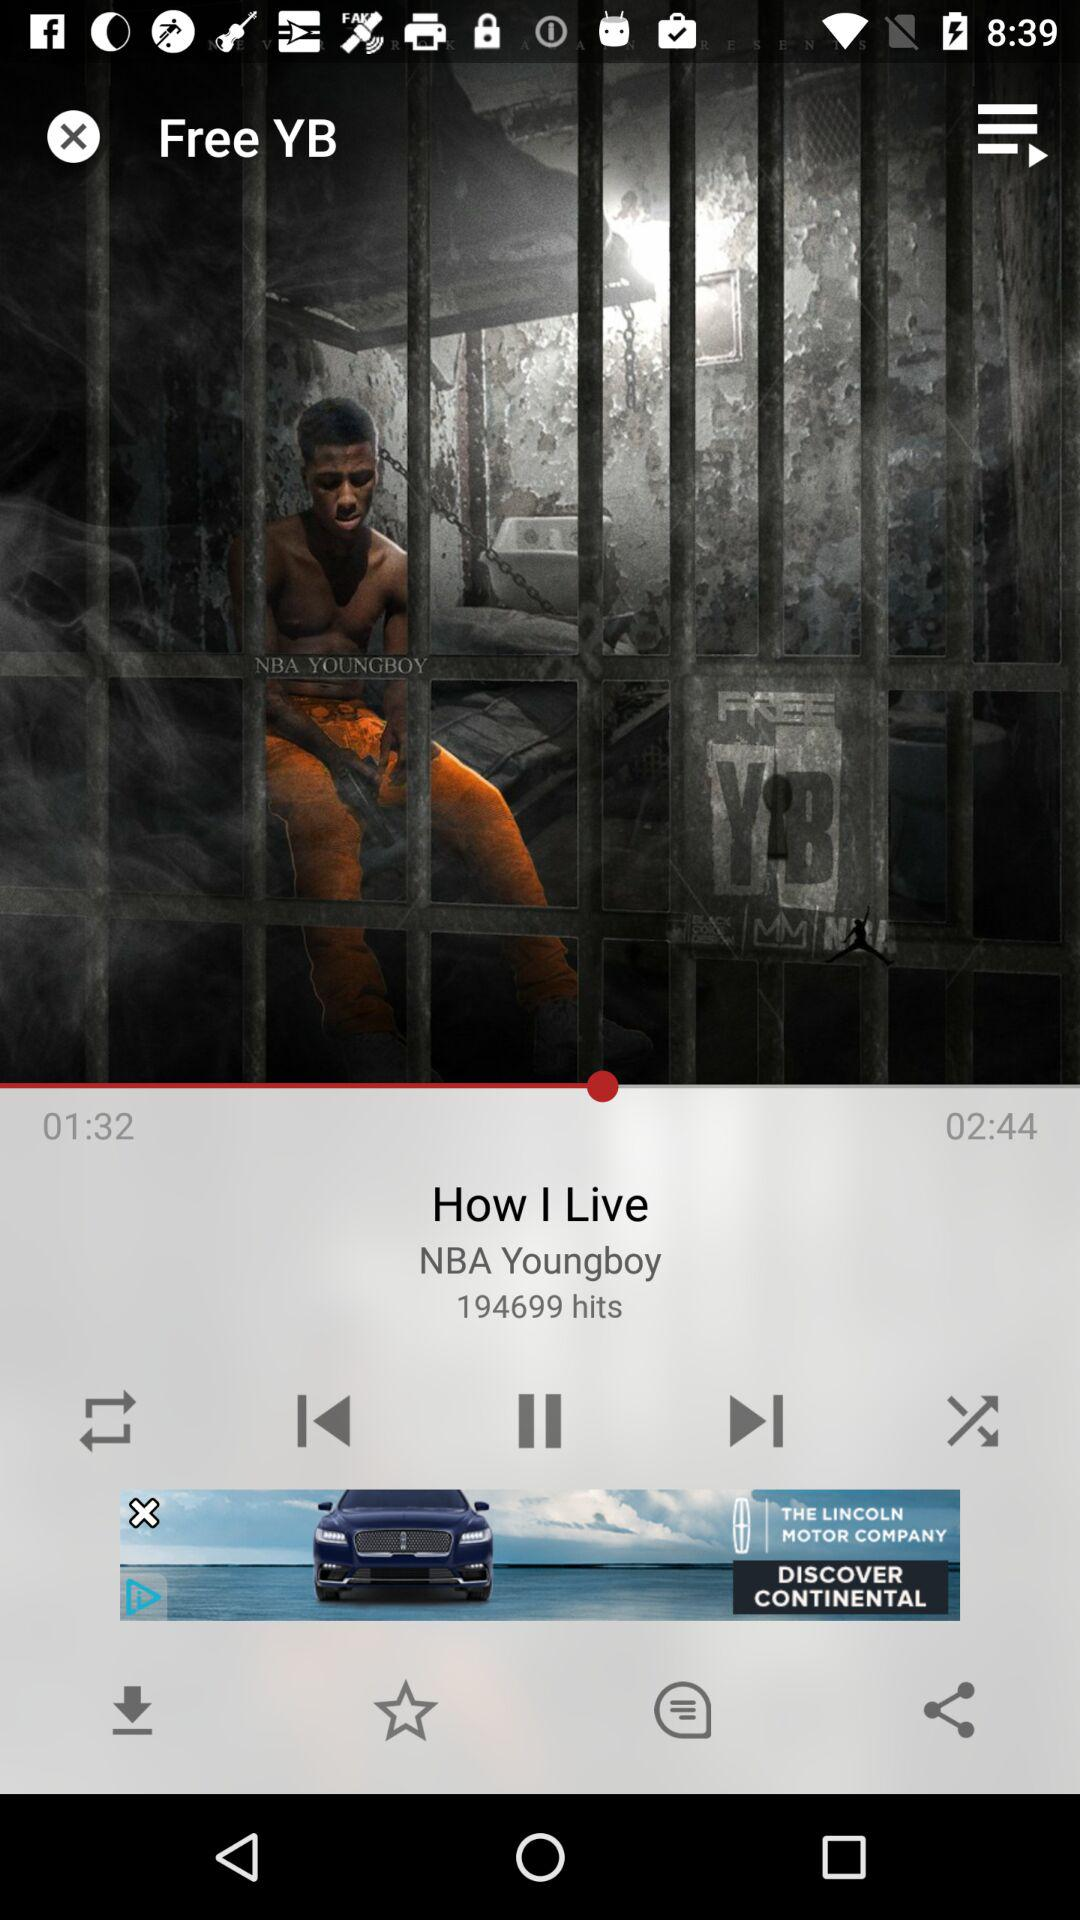Who is the singer of the song? The singer of the song is NBA Youngboy. 